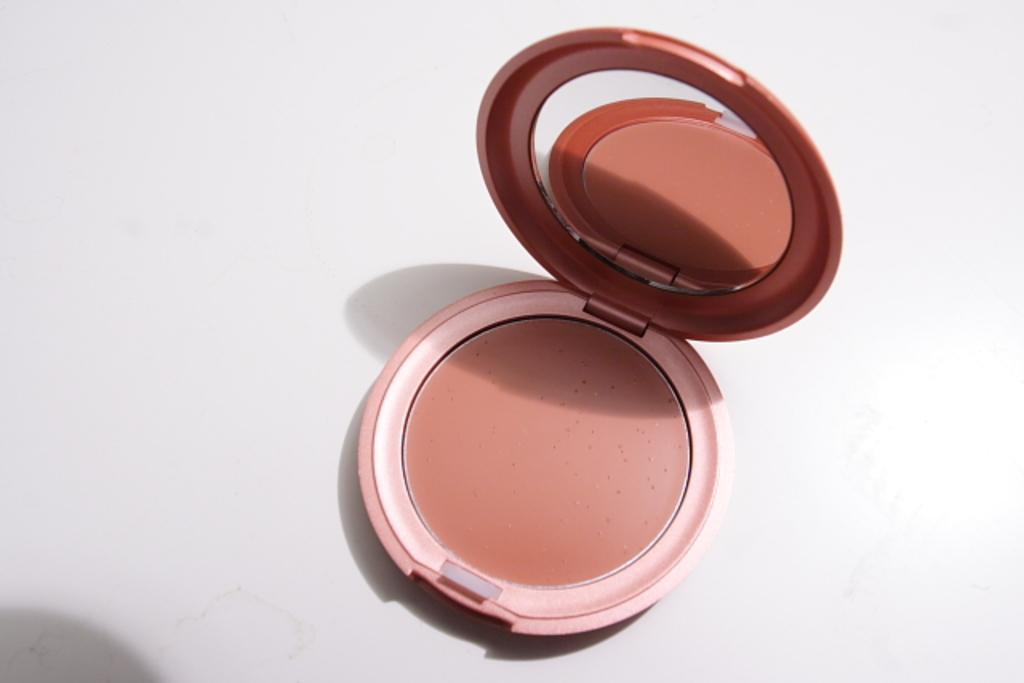How would you summarize this image in a sentence or two? In the center of the image we can see a compact powder placed on the table. 